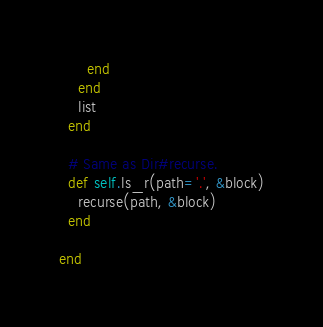Convert code to text. <code><loc_0><loc_0><loc_500><loc_500><_Ruby_>      end
    end
    list
  end

  # Same as Dir#recurse.
  def self.ls_r(path='.', &block)
    recurse(path, &block)
  end

end

</code> 